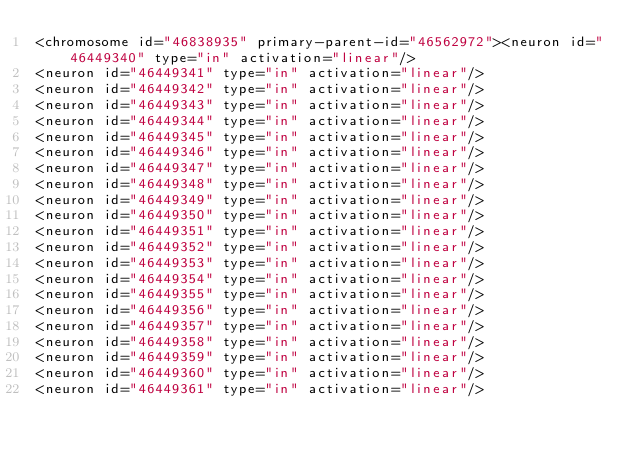Convert code to text. <code><loc_0><loc_0><loc_500><loc_500><_XML_><chromosome id="46838935" primary-parent-id="46562972"><neuron id="46449340" type="in" activation="linear"/>
<neuron id="46449341" type="in" activation="linear"/>
<neuron id="46449342" type="in" activation="linear"/>
<neuron id="46449343" type="in" activation="linear"/>
<neuron id="46449344" type="in" activation="linear"/>
<neuron id="46449345" type="in" activation="linear"/>
<neuron id="46449346" type="in" activation="linear"/>
<neuron id="46449347" type="in" activation="linear"/>
<neuron id="46449348" type="in" activation="linear"/>
<neuron id="46449349" type="in" activation="linear"/>
<neuron id="46449350" type="in" activation="linear"/>
<neuron id="46449351" type="in" activation="linear"/>
<neuron id="46449352" type="in" activation="linear"/>
<neuron id="46449353" type="in" activation="linear"/>
<neuron id="46449354" type="in" activation="linear"/>
<neuron id="46449355" type="in" activation="linear"/>
<neuron id="46449356" type="in" activation="linear"/>
<neuron id="46449357" type="in" activation="linear"/>
<neuron id="46449358" type="in" activation="linear"/>
<neuron id="46449359" type="in" activation="linear"/>
<neuron id="46449360" type="in" activation="linear"/>
<neuron id="46449361" type="in" activation="linear"/></code> 